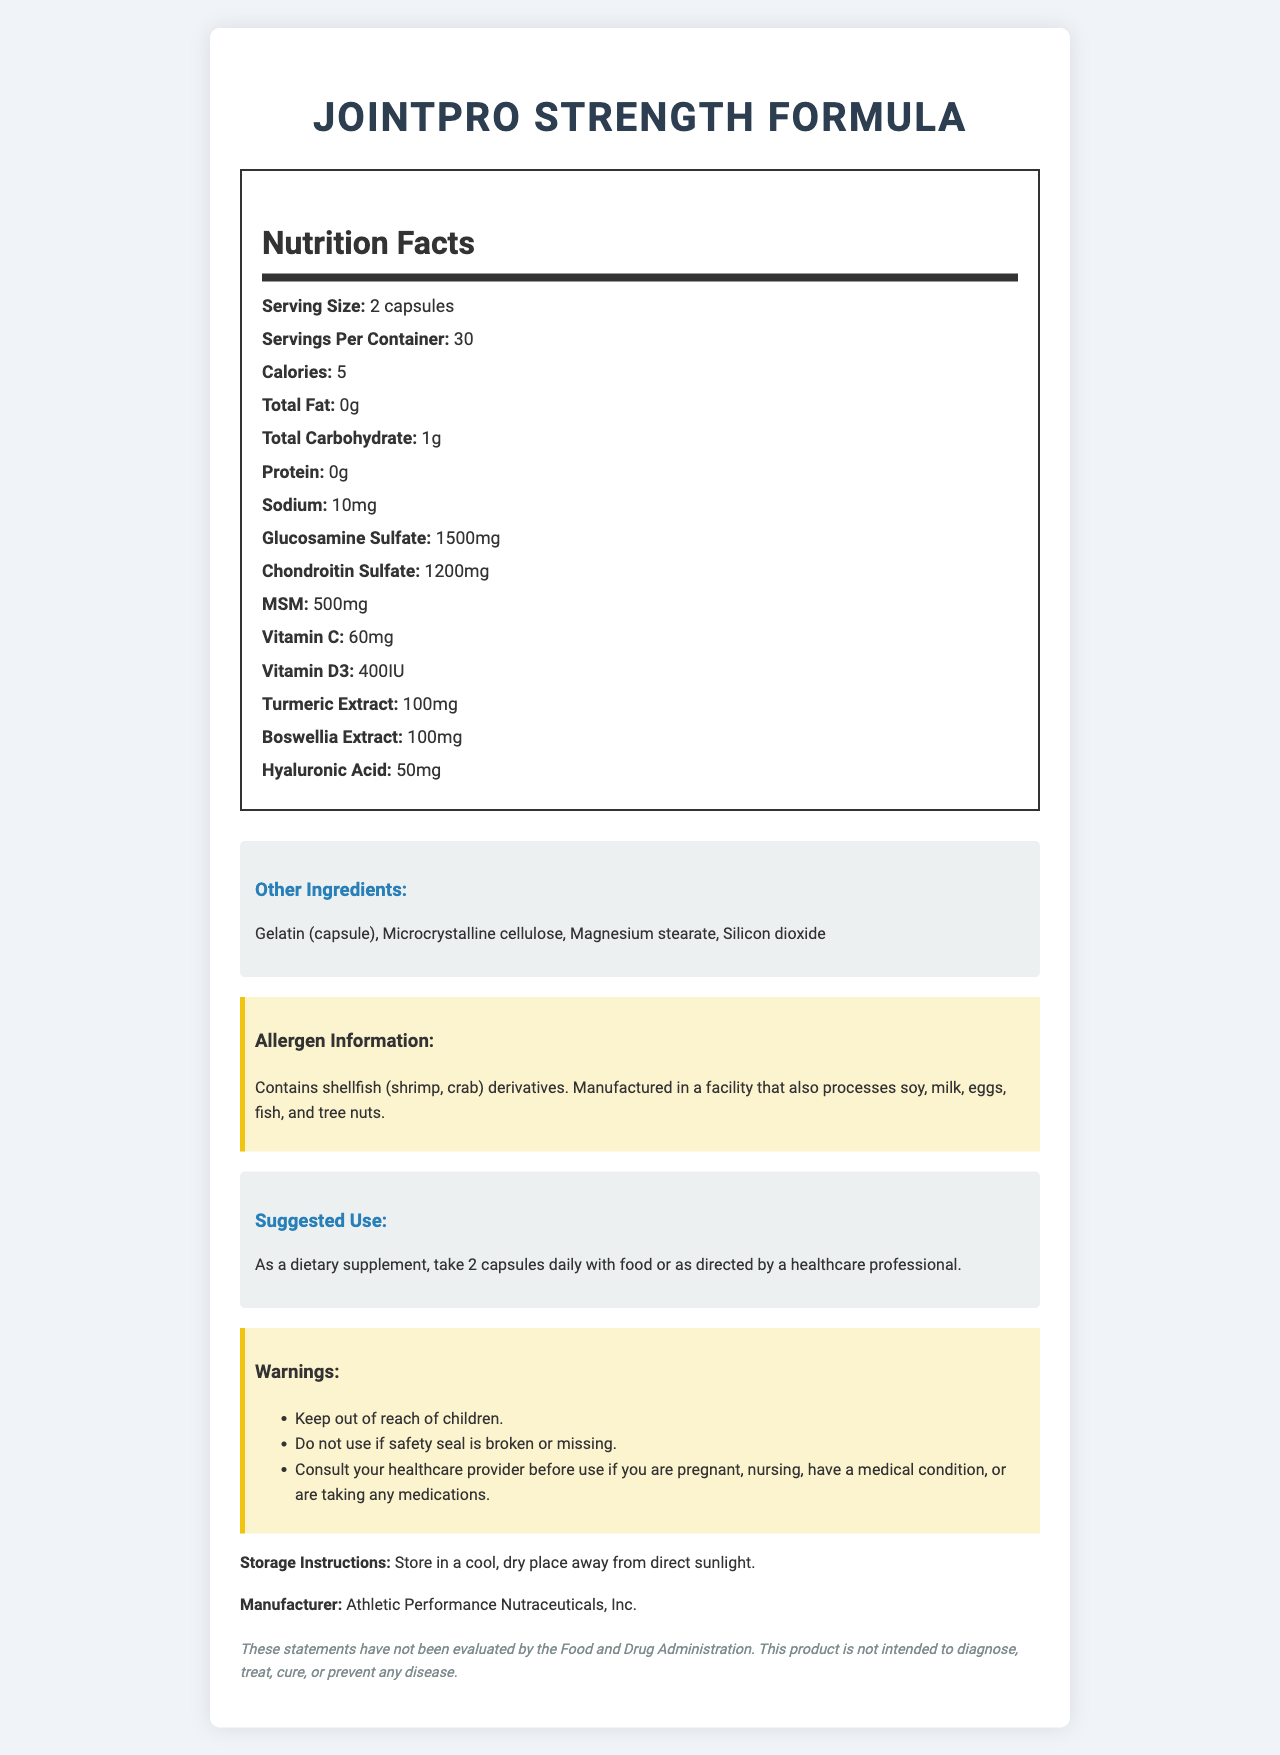what is the serving size? The document states that the serving size is 2 capsules.
Answer: 2 capsules how many calories are there per serving? The document indicates that there are 5 calories per serving.
Answer: 5 calories which ingredient has the highest quantity per serving? The document lists Glucosamine Sulfate with 1500 mg per serving, which is higher than any other ingredient.
Answer: Glucosamine Sulfate do the capsules contain any sodium? The document mentions that the capsules contain 10 mg of sodium.
Answer: Yes what are the suggested use instructions? The document provides the suggested use instructions under that specific section.
Answer: Take 2 capsules daily with food or as directed by a healthcare professional which of the following is an ingredient found in the capsules? A. Calcium B. Iron C. Turmeric Extract D. Potassium The document lists Turmeric Extract as an ingredient, but does not mention Calcium, Iron, or Potassium.
Answer: C. Turmeric Extract how many servings are there per container? The document states that there are 30 servings per container.
Answer: 30 servings does the supplement contain any allergens? The allergen information section specifies that the product contains shellfish (shrimp, crab) derivatives.
Answer: Yes, it contains shellfish (shrimp, crab) derivatives. is this supplement intended to diagnose, treat, cure, or prevent any disease? The disclaimer states that the product is not intended to diagnose, treat, cure, or prevent any disease.
Answer: No what are the storage instructions for this supplement? The document lists the storage instructions as "Store in a cool dry place away from direct sunlight."
Answer: Store in a cool, dry place away from direct sunlight. how much Vitamin C is in each serving? The document states that there is 60 mg of Vitamin C per serving.
Answer: 60 mg which company manufactures this supplement? A. HealthPro Inc. B. Athletic Performance Nutraceuticals, Inc. C. Wellness Formulas Co. The document mentions that the supplement is manufactured by Athletic Performance Nutraceuticals, Inc.
Answer: B. Athletic Performance Nutraceuticals, Inc. is the product safe for children to use? The warnings section clearly states to keep out of reach of children.
Answer: No summarize the main details of this document. This summary outlines the key details of the nutrition facts, ingredients, allergen information, suggested use, warning, storage instructions, and manufacturer information included in the document.
Answer: The JointPro Strength Formula is a joint health supplement featuring Glucosamine and Chondroitin. Each serving size is 2 capsules, with 30 servings per container. It contains calories, sodium, and multiple active ingredients such as Glucosamine Sulfate, Chondroitin Sulfate, MSM, Vitamin C, Vitamin D3, Turmeric Extract, Boswellia Extract, and Hyaluronic Acid. The other ingredients include Gelatin (capsule), Microcrystalline cellulose, Magnesium stearate, and Silicon dioxide. The product contains shellfish derivatives and is manufactured in a facility that processes other allergens. It is recommended to take 2 capsules daily with food, and the product must be stored in a cool, dry place away from direct sunlight. The manufacturer is Athletic Performance Nutraceuticals, Inc., and the product is not intended to diagnose, treat, cure, or prevent any disease. what are the benefits of taking this supplement? The document does not provide information about the specific benefits of taking this supplement; it only lists the ingredients and other product details.
Answer: Not enough information 